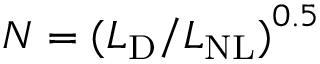Convert formula to latex. <formula><loc_0><loc_0><loc_500><loc_500>N = { ( L _ { D } / L _ { N L } ) } ^ { 0 . 5 }</formula> 